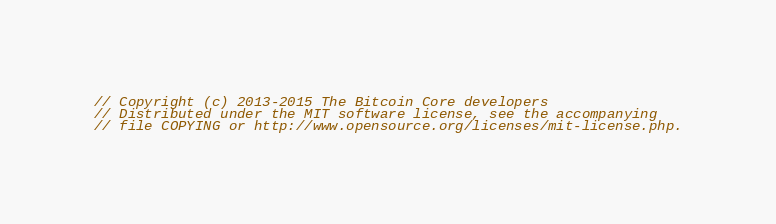Convert code to text. <code><loc_0><loc_0><loc_500><loc_500><_C++_>// Copyright (c) 2013-2015 The Bitcoin Core developers
// Distributed under the MIT software license, see the accompanying
// file COPYING or http://www.opensource.org/licenses/mit-license.php.
</code> 